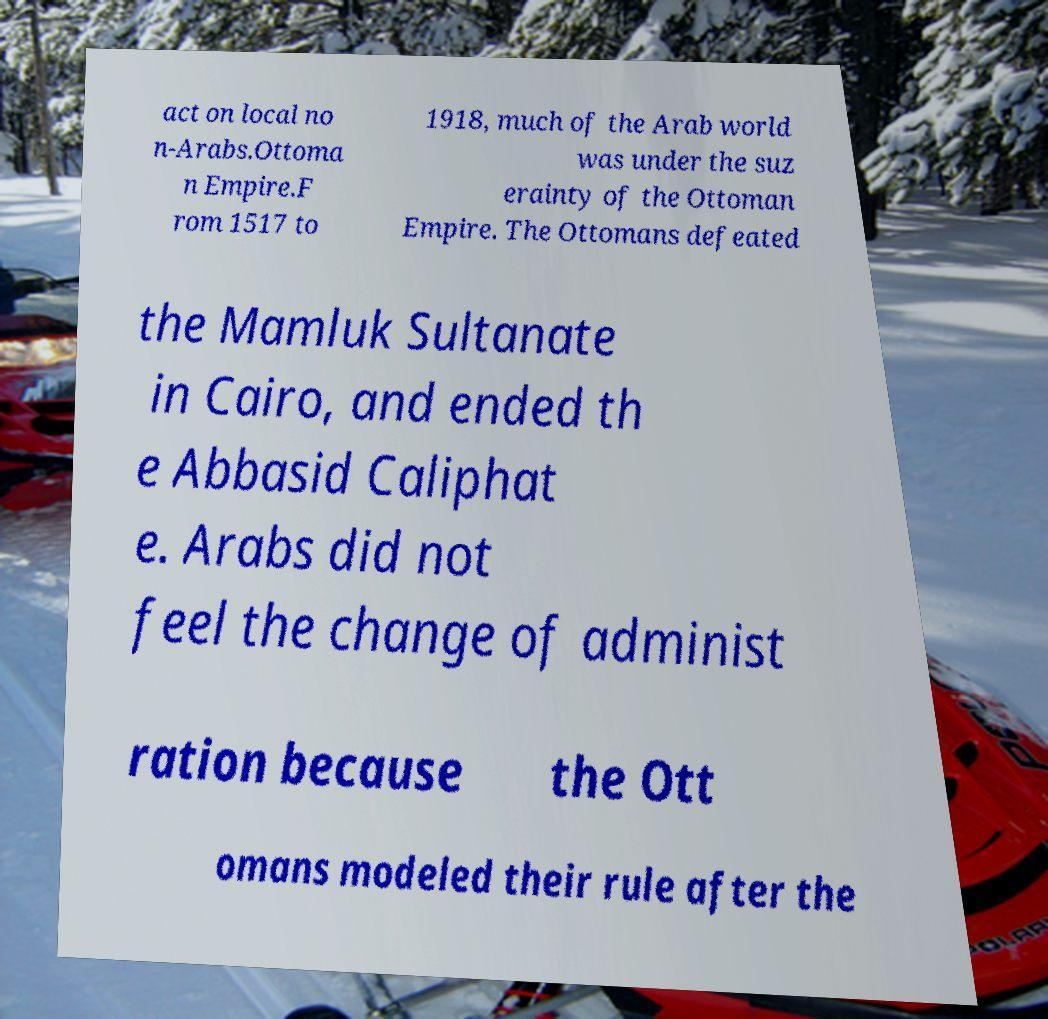Could you extract and type out the text from this image? act on local no n-Arabs.Ottoma n Empire.F rom 1517 to 1918, much of the Arab world was under the suz erainty of the Ottoman Empire. The Ottomans defeated the Mamluk Sultanate in Cairo, and ended th e Abbasid Caliphat e. Arabs did not feel the change of administ ration because the Ott omans modeled their rule after the 